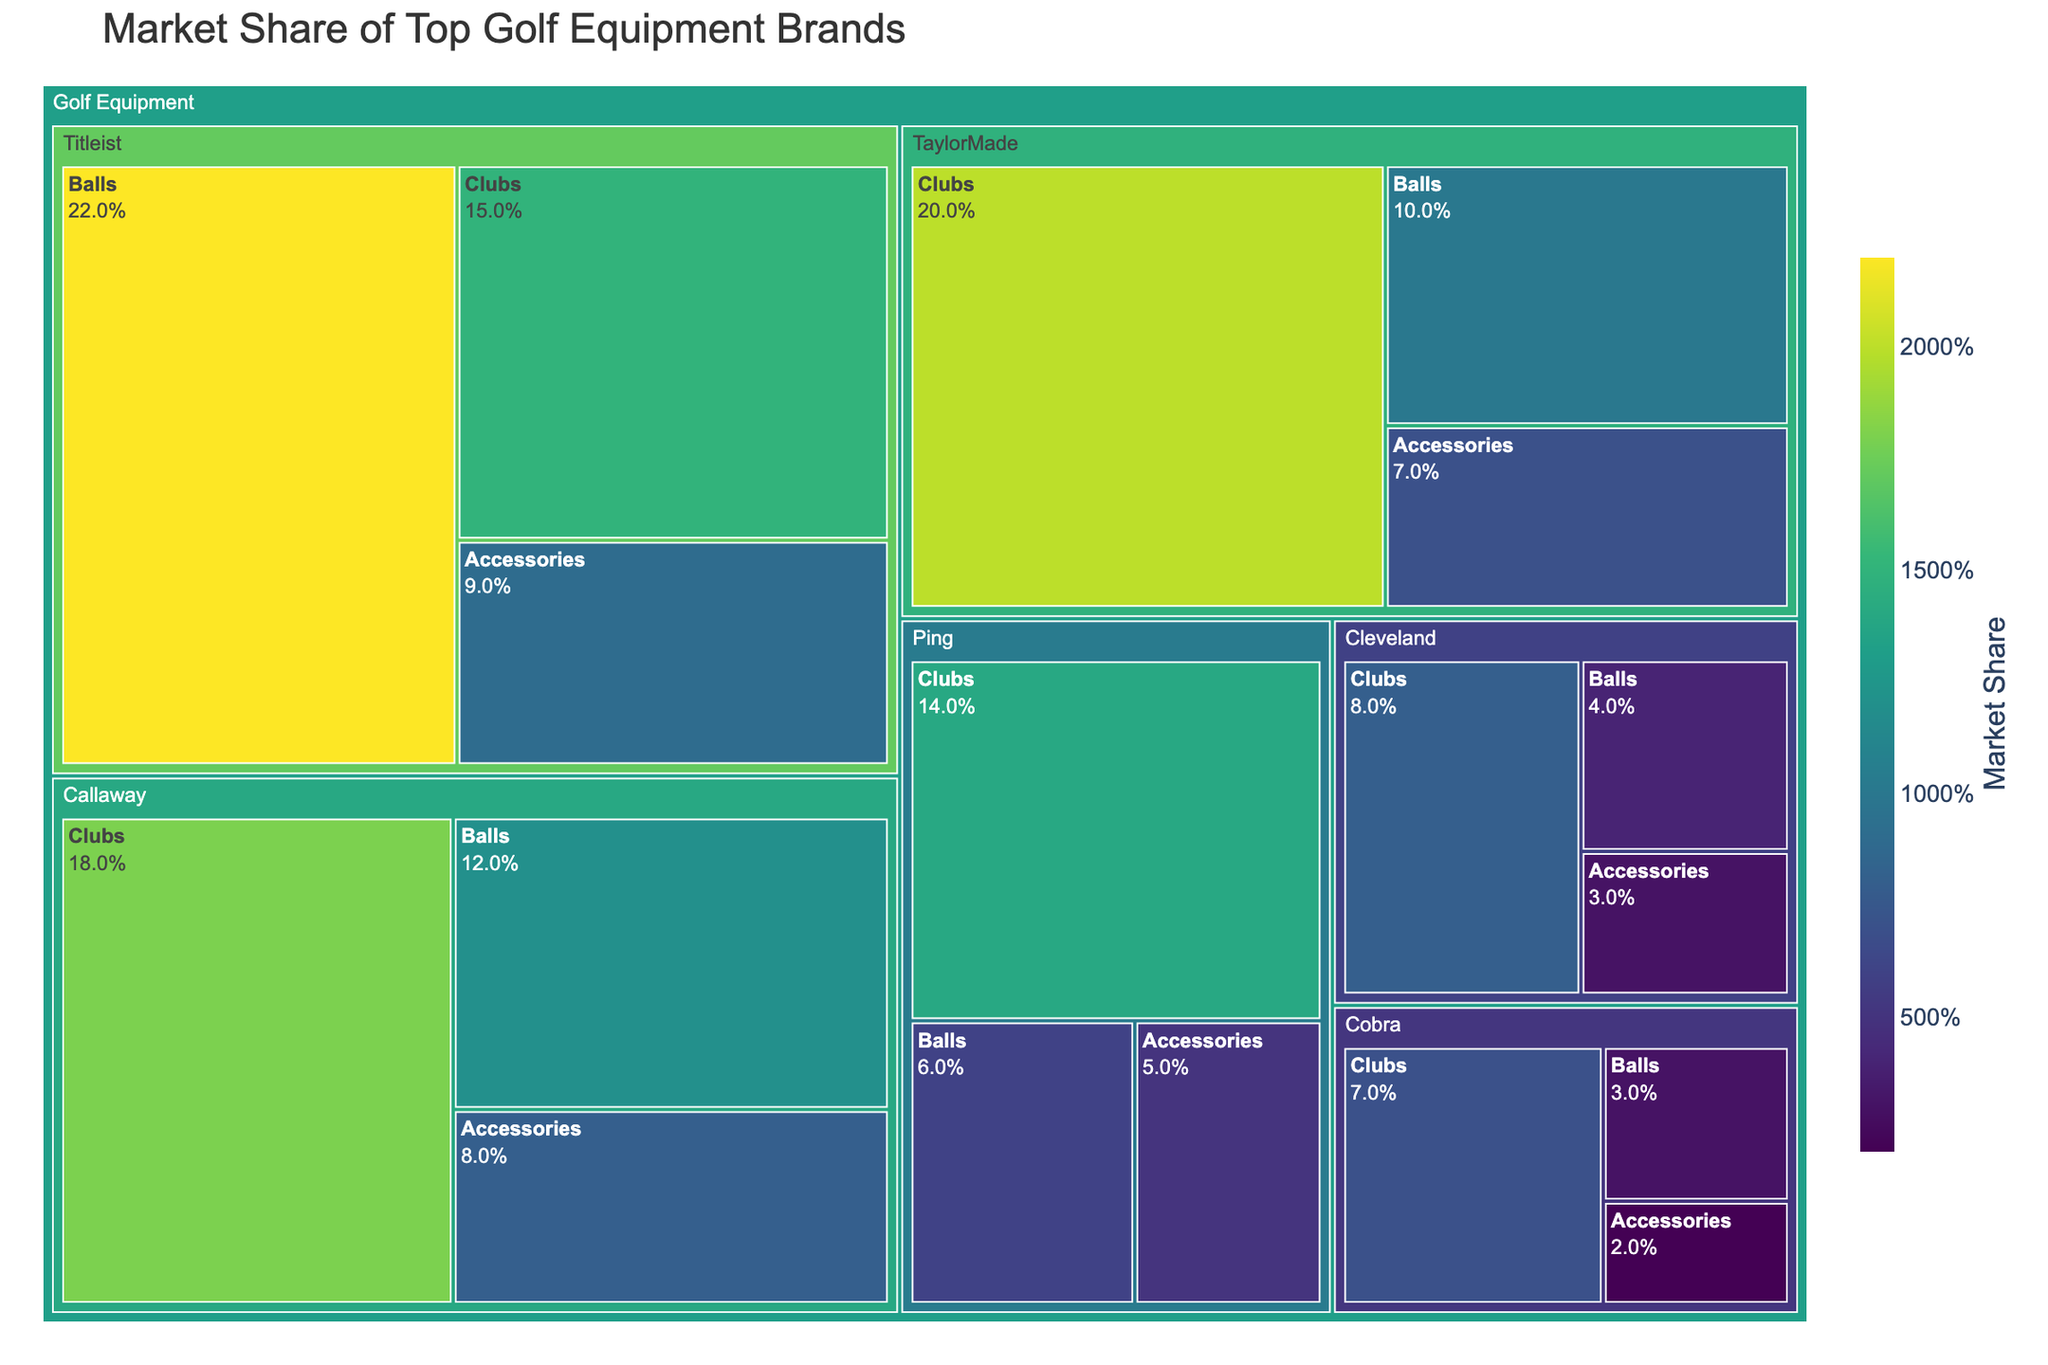How many brands are depicted in the treemap? By visually scanning the treemap, you can count the number of distinct brands. The brands present are Callaway, TaylorMade, Titleist, Ping, Cleveland, and Cobra.
Answer: 6 Which brand has the largest total market share in golf equipment? To determine which brand has the largest total market share, add the market shares for clubs, balls, and accessories. TaylorMade has the highest combined share: 20 (Clubs) + 10 (Balls) + 7 (Accessories) = 37%.
Answer: TaylorMade What is the combined market share of Titleist balls and accessories? Identify the market share for Titleist balls (22%) and Titleist accessories (9%), then sum them up: 22% + 9% = 31%.
Answer: 31% Which product category does Callaway have the smallest market share in? By comparing the market shares of Callaway's products, you identify that Accessories has the smallest share at 8%.
Answer: Accessories How does the market share of TaylorMade clubs compare to Ping clubs? Compare the market shares given for TaylorMade clubs (20%) and Ping clubs (14%). TaylorMade clubs have a 6% higher market share than Ping clubs.
Answer: TaylorMade has 6% more What's the difference in market share between Titleist and Cleveland in the balls category? Subtract Cleveland's market share in balls (4%) from Titleist's market share in balls (22%): 22% - 4% = 18%.
Answer: 18% Which brand has the smallest market share for accessories, and what is the share? Identify the smallest market share in the Accessories subcategory. Cobra has the smallest share at 2%.
Answer: Cobra with 2% Rank the brands by their market share in the clubs category. Compare the market shares in the clubs subcategory: TaylorMade (20%), Callaway (18%), Titleist (15%), Ping (14%), Cleveland (8%), and Cobra (7%). Ranking them from highest to lowest: TaylorMade, Callaway, Titleist, Ping, Cleveland, Cobra.
Answer: TaylorMade, Callaway, Titleist, Ping, Cleveland, Cobra What is the total market share of all accessories across all brands? Sum the market shares of accessories for each brand: Callaway (8%) + TaylorMade (7%) + Titleist (9%) + Ping (5%) + Cleveland (3%) + Cobra (2%): 8% + 7% + 9% + 5% + 3% + 2% = 34%.
Answer: 34% Which brand has the most balanced market share across clubs, balls, and accessories, and why? A brand with roughly equal shares across all three product categories would be considered balanced. Titleist shows relatively balanced shares with 15% in clubs, 22% in balls, and 9% in accessories.
Answer: Titleist 